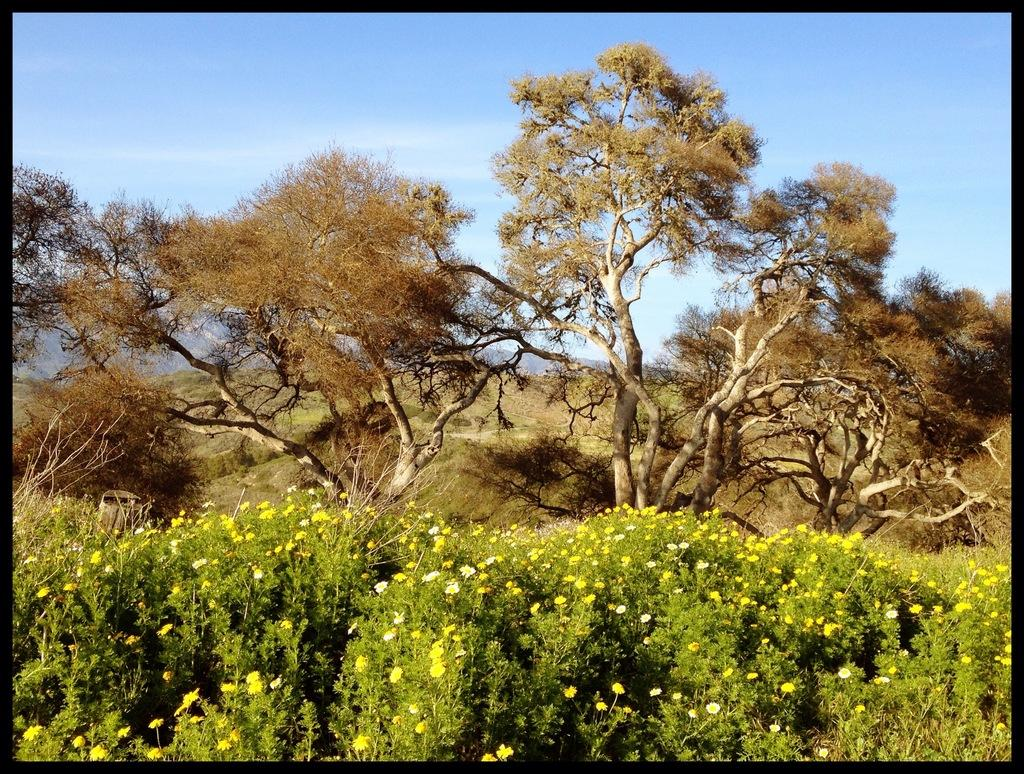What type of vegetation can be seen in the image? There are trees and plants with flowers in the image. Can you describe the sky in the image? The sky is blue and cloudy in the image. What story is being told by the earth in the image? There is no story being told by the earth in the image, as the image does not contain any reference to the earth. 